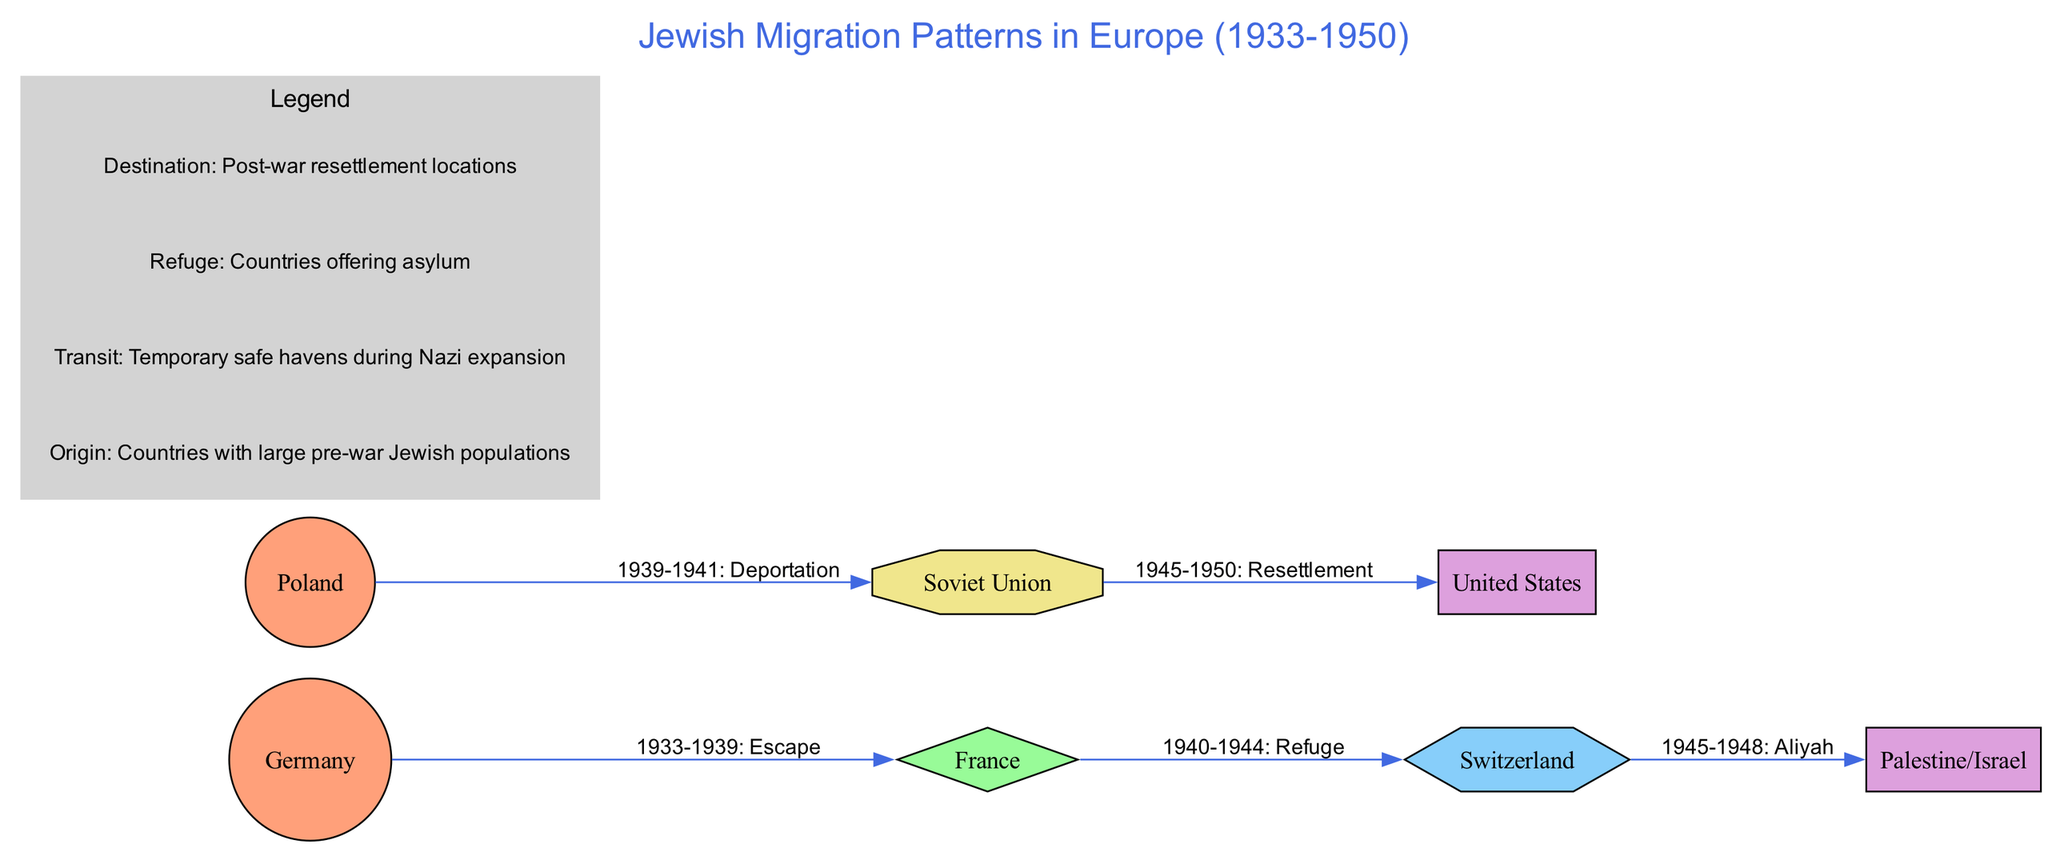What is the total number of nodes in the diagram? The diagram features 7 nodes, which include origin, transit, refuge, and destination types of locations. These can be counted directly by numbering them as they are outlined in the data.
Answer: 7 Which country served as a transit location during the migration patterns? According to the diagram, France is identified as the transit location. This is evident in the node types and labeling which indicate its role during the specified years.
Answer: France What relationship is indicated between Germany and France? The relationship shown between Germany and France is labeled "1933-1939: Escape." This clearly indicates the nature of movement from Germany to France as a means to escape persecution.
Answer: Escape How many edges are shown in the diagram? The diagram consists of 5 edges, as represented in the edges section of the data. Each edge connects two nodes and indicates a specific migration path or transition.
Answer: 5 Which destination is associated with the label "1945-1948: Aliyah"? The label "1945-1948: Aliyah" connects to Palestine/Israel, signifying the post-war immigration of Jewish people to that location during these years. This is derived from the specific edge labeling in the diagram.
Answer: Palestine/Israel What type of location is the Soviet Union classified as in this diagram? The Soviet Union is classified as a "Refuge/Transit" location. This type is explicitly outlined in the node descriptions, indicating its dual role during the migrations.
Answer: Refuge/Transit Which origin country had a deportation relationship with the Soviet Union? The origin country that had a deportation relationship with the Soviet Union is Poland, which is noted in the edges section with a timeline indicating movement during the stated years.
Answer: Poland What type of node is Switzerland categorized as? Switzerland is categorized as a "Refuge" node. This description is provided in the node type section, highlighting its role as a country that offered asylum during migration.
Answer: Refuge 